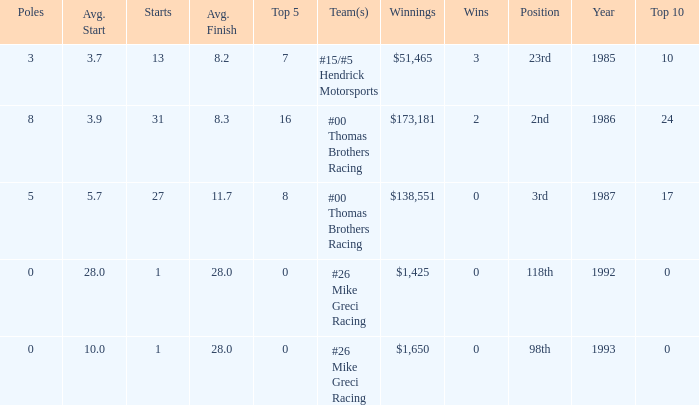What was the average finish the year Bodine finished 3rd? 11.7. 